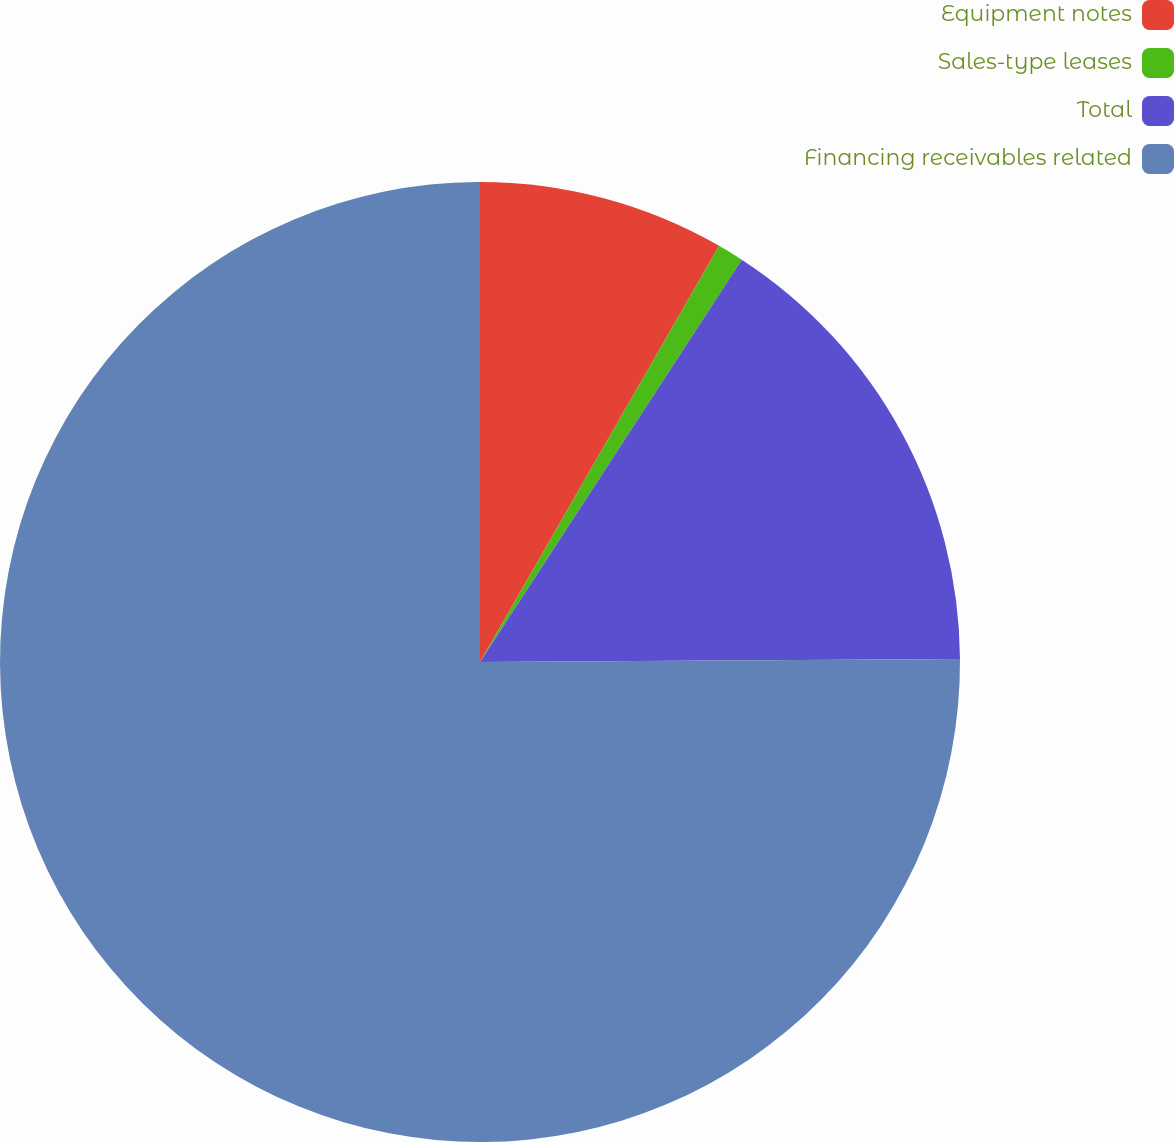<chart> <loc_0><loc_0><loc_500><loc_500><pie_chart><fcel>Equipment notes<fcel>Sales-type leases<fcel>Total<fcel>Financing receivables related<nl><fcel>8.3%<fcel>0.88%<fcel>15.72%<fcel>75.1%<nl></chart> 